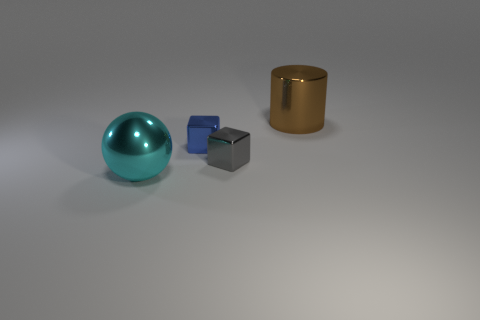Considering the arrangement of the objects, what mood or theme could this represent? The deliberate and solitary placement of the objects against the neutral background could evoke themes of simplicity and minimalism. The contrasting shapes and sizes might represent diversity or individuality, and the calm lighting imparts a serene and contemplative mood to the scene, inviting the viewer to reflect on the interplay between form and space. 